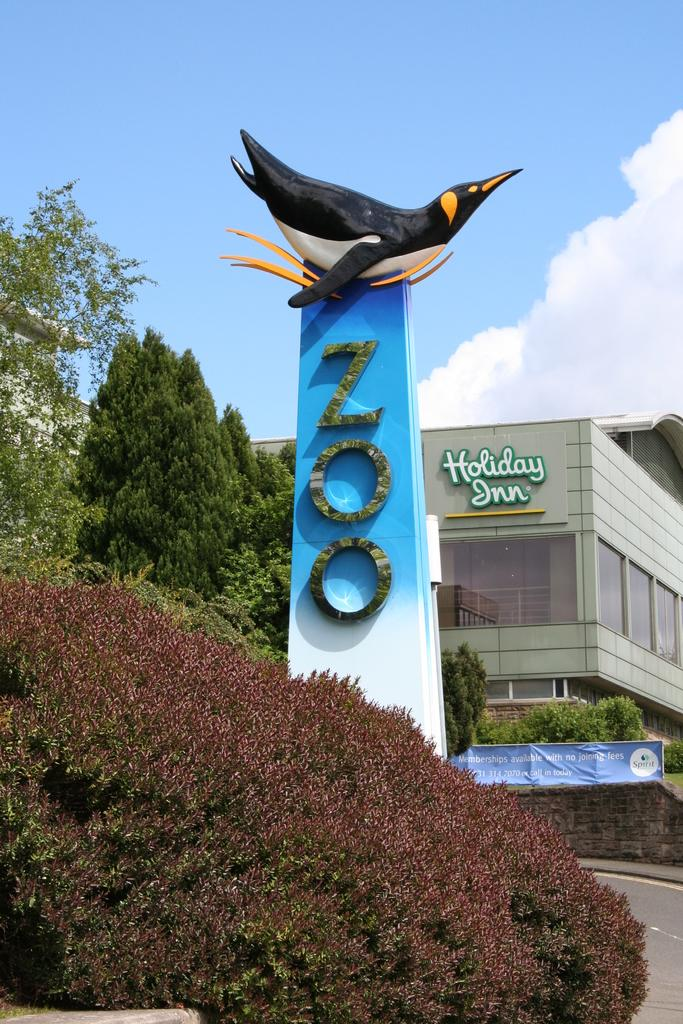What is the main subject of the image? There is a zoo memorial in the image. What can be seen in the background of the image? There is a building in the background of the image. What type of vegetation is present in the image? Trees and shrubs are visible in the image. What is visible at the top of the image? The sky is visible at the top of the image. What is the condition of the sky in the image? Clouds are present in the sky. Is the zoo memorial open at night in the image? The time of day is not specified in the image, so it cannot be determined if the zoo memorial is open at night. Are there any animals, such as a zebra, visible in the image? There are no animals visible in the image; it features a zoo memorial, building, trees, shrubs, and a cloudy sky. 